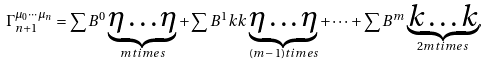<formula> <loc_0><loc_0><loc_500><loc_500>\Gamma _ { n + 1 } ^ { \mu _ { 0 } \cdots \mu _ { n } } = \sum B ^ { 0 } \underbrace { \eta \dots \eta } _ { m t i m e s } + \sum B ^ { 1 } k k \underbrace { \eta \dots \eta } _ { ( m \, - \, 1 ) t i m e s } + \dots + \sum B ^ { m } \underbrace { k \dots k } _ { 2 m t i m e s } ,</formula> 